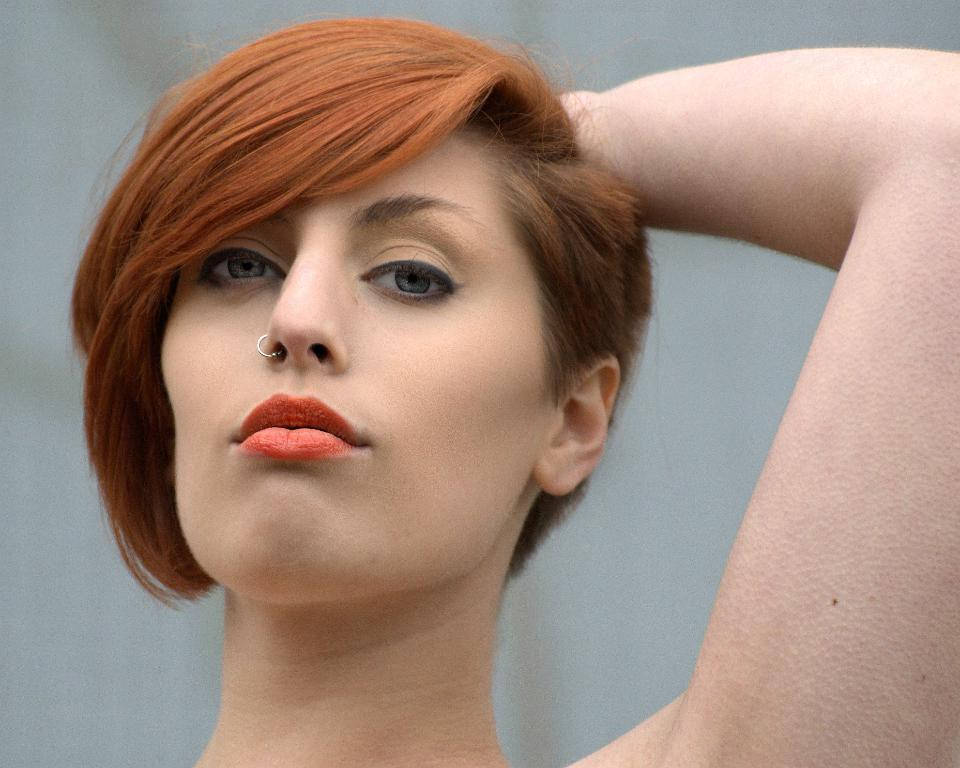Who is present in the image? There is a woman in the image. What year does the woman in the image tend to add to her age? There is no information about the woman's age or tendency to add a specific year to her age in the image. 